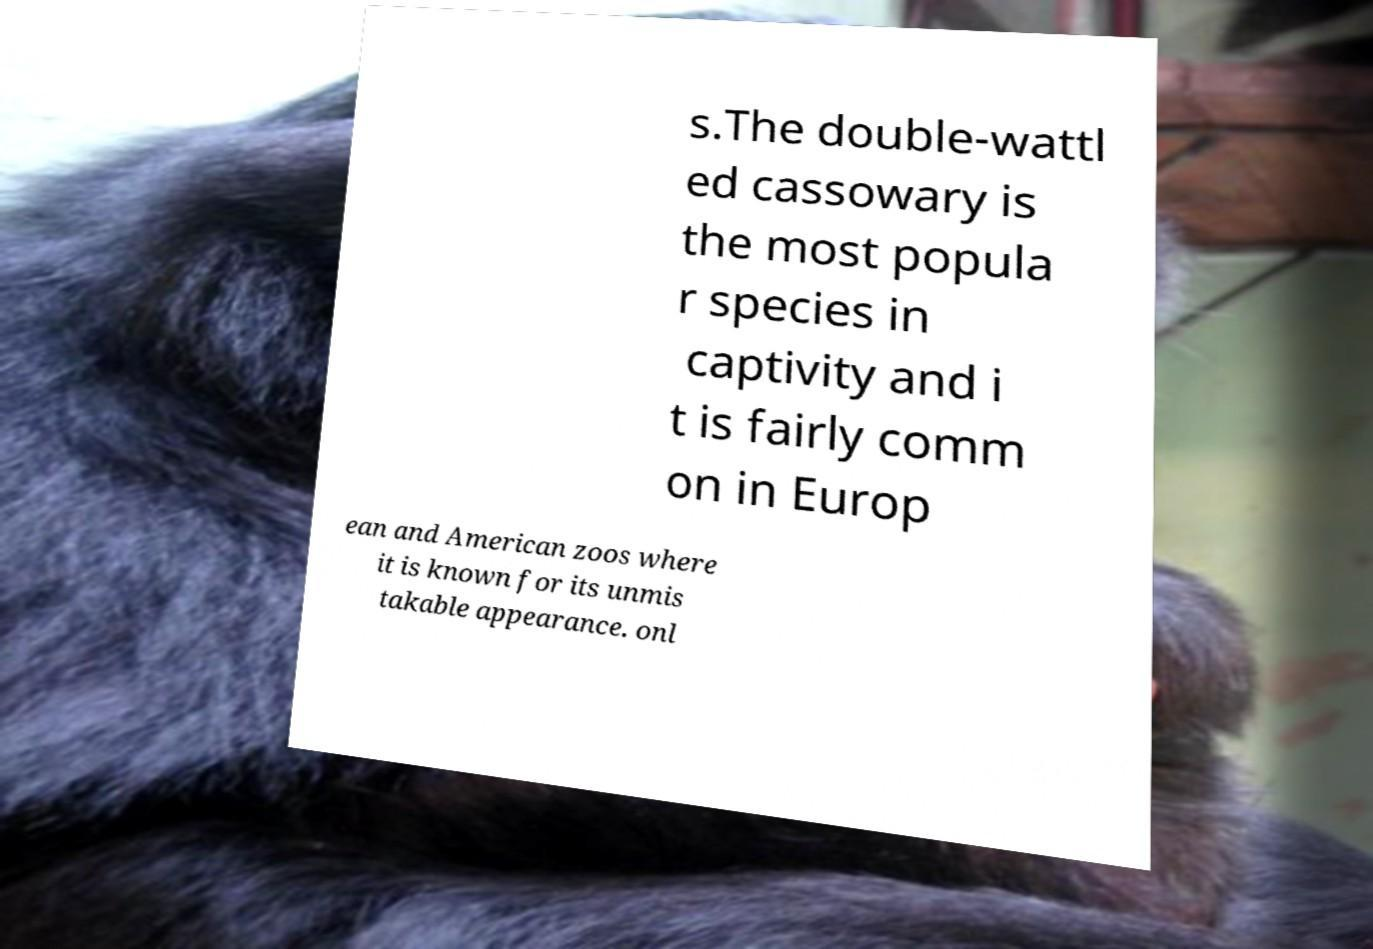Could you assist in decoding the text presented in this image and type it out clearly? s.The double-wattl ed cassowary is the most popula r species in captivity and i t is fairly comm on in Europ ean and American zoos where it is known for its unmis takable appearance. onl 